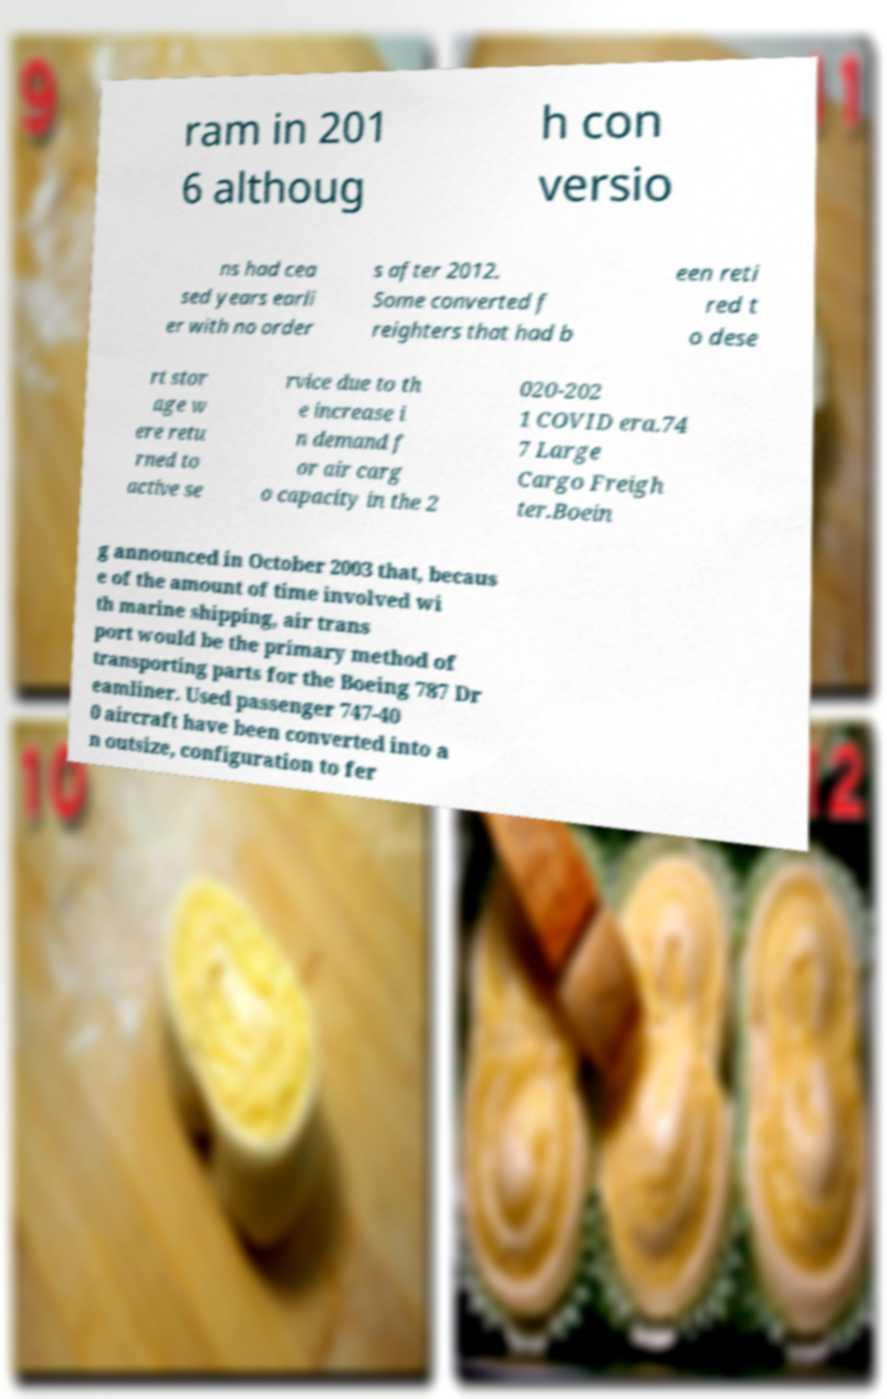Please identify and transcribe the text found in this image. ram in 201 6 althoug h con versio ns had cea sed years earli er with no order s after 2012. Some converted f reighters that had b een reti red t o dese rt stor age w ere retu rned to active se rvice due to th e increase i n demand f or air carg o capacity in the 2 020-202 1 COVID era.74 7 Large Cargo Freigh ter.Boein g announced in October 2003 that, becaus e of the amount of time involved wi th marine shipping, air trans port would be the primary method of transporting parts for the Boeing 787 Dr eamliner. Used passenger 747-40 0 aircraft have been converted into a n outsize, configuration to fer 